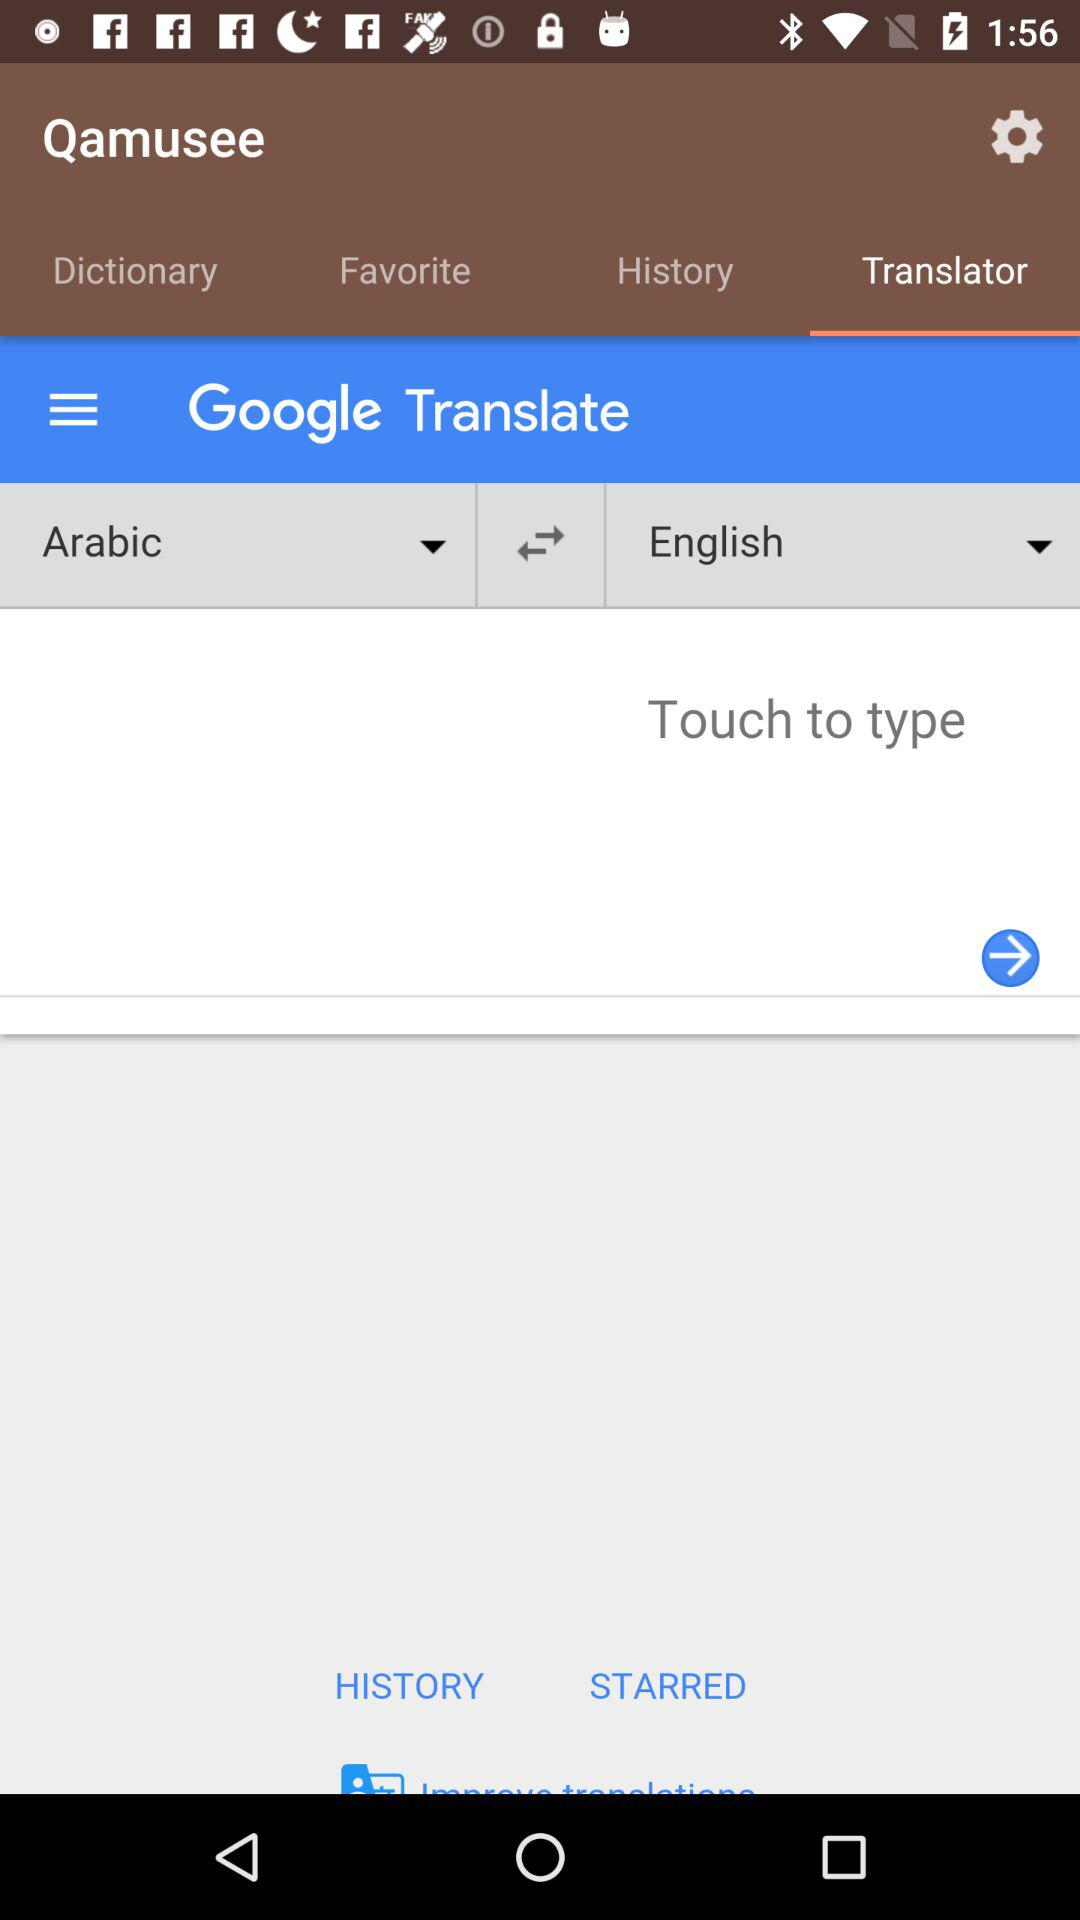What word is being translated?
When the provided information is insufficient, respond with <no answer>. <no answer> 